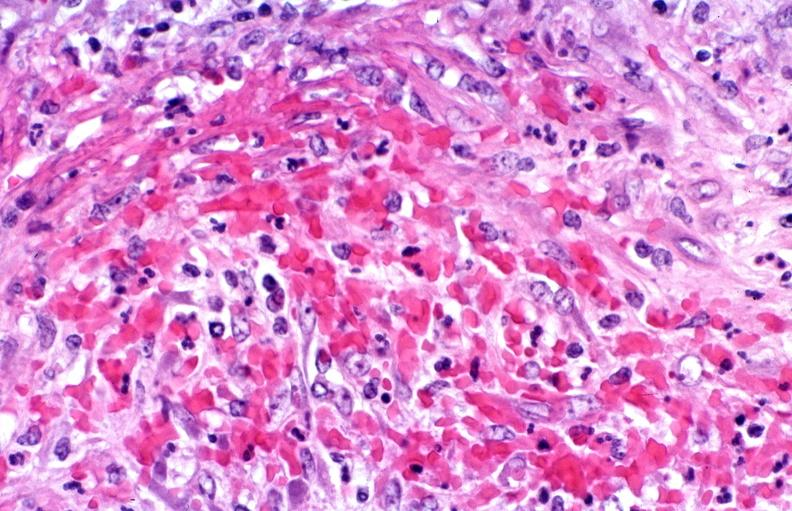s beckwith-wiedemann syndrome present?
Answer the question using a single word or phrase. No 